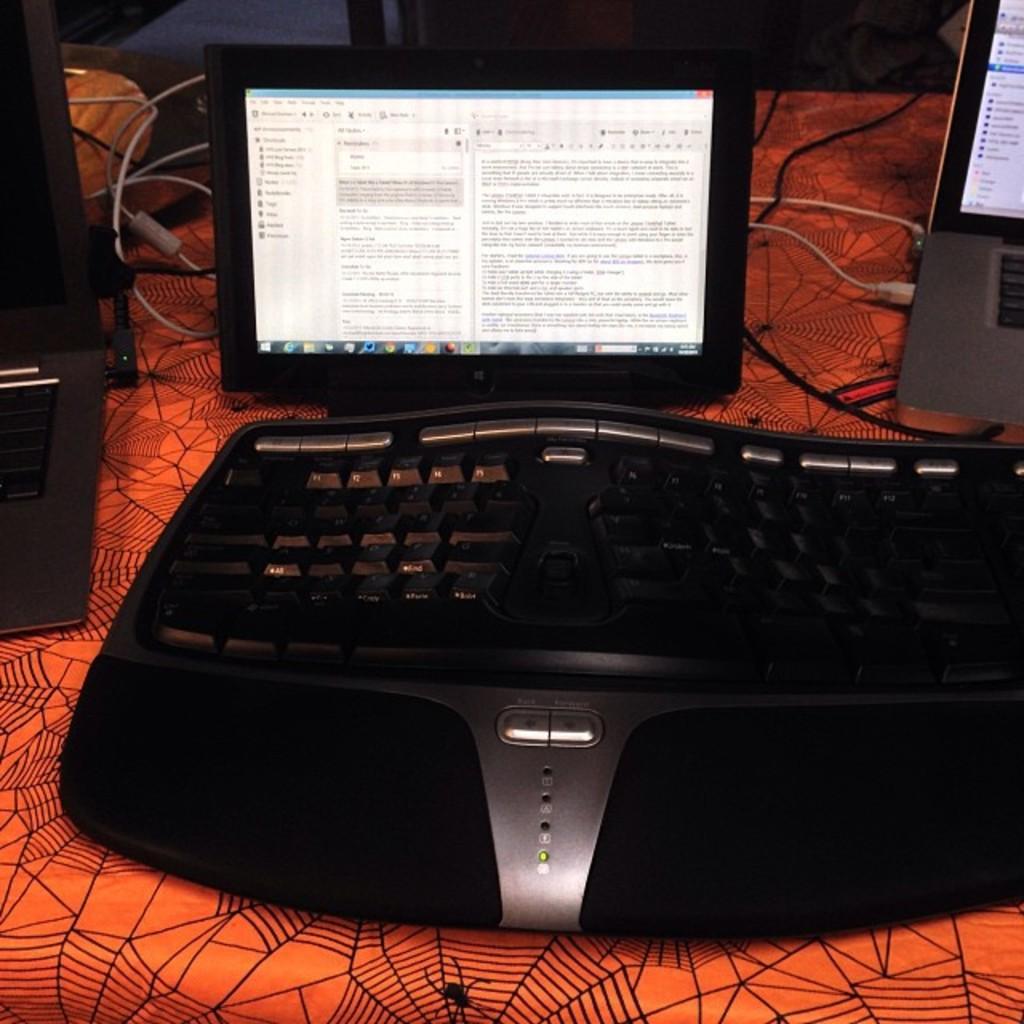Could you give a brief overview of what you see in this image? There is a monitor, laptop, keyboard and other objects on a table. Which is covered with an orange color cover. 